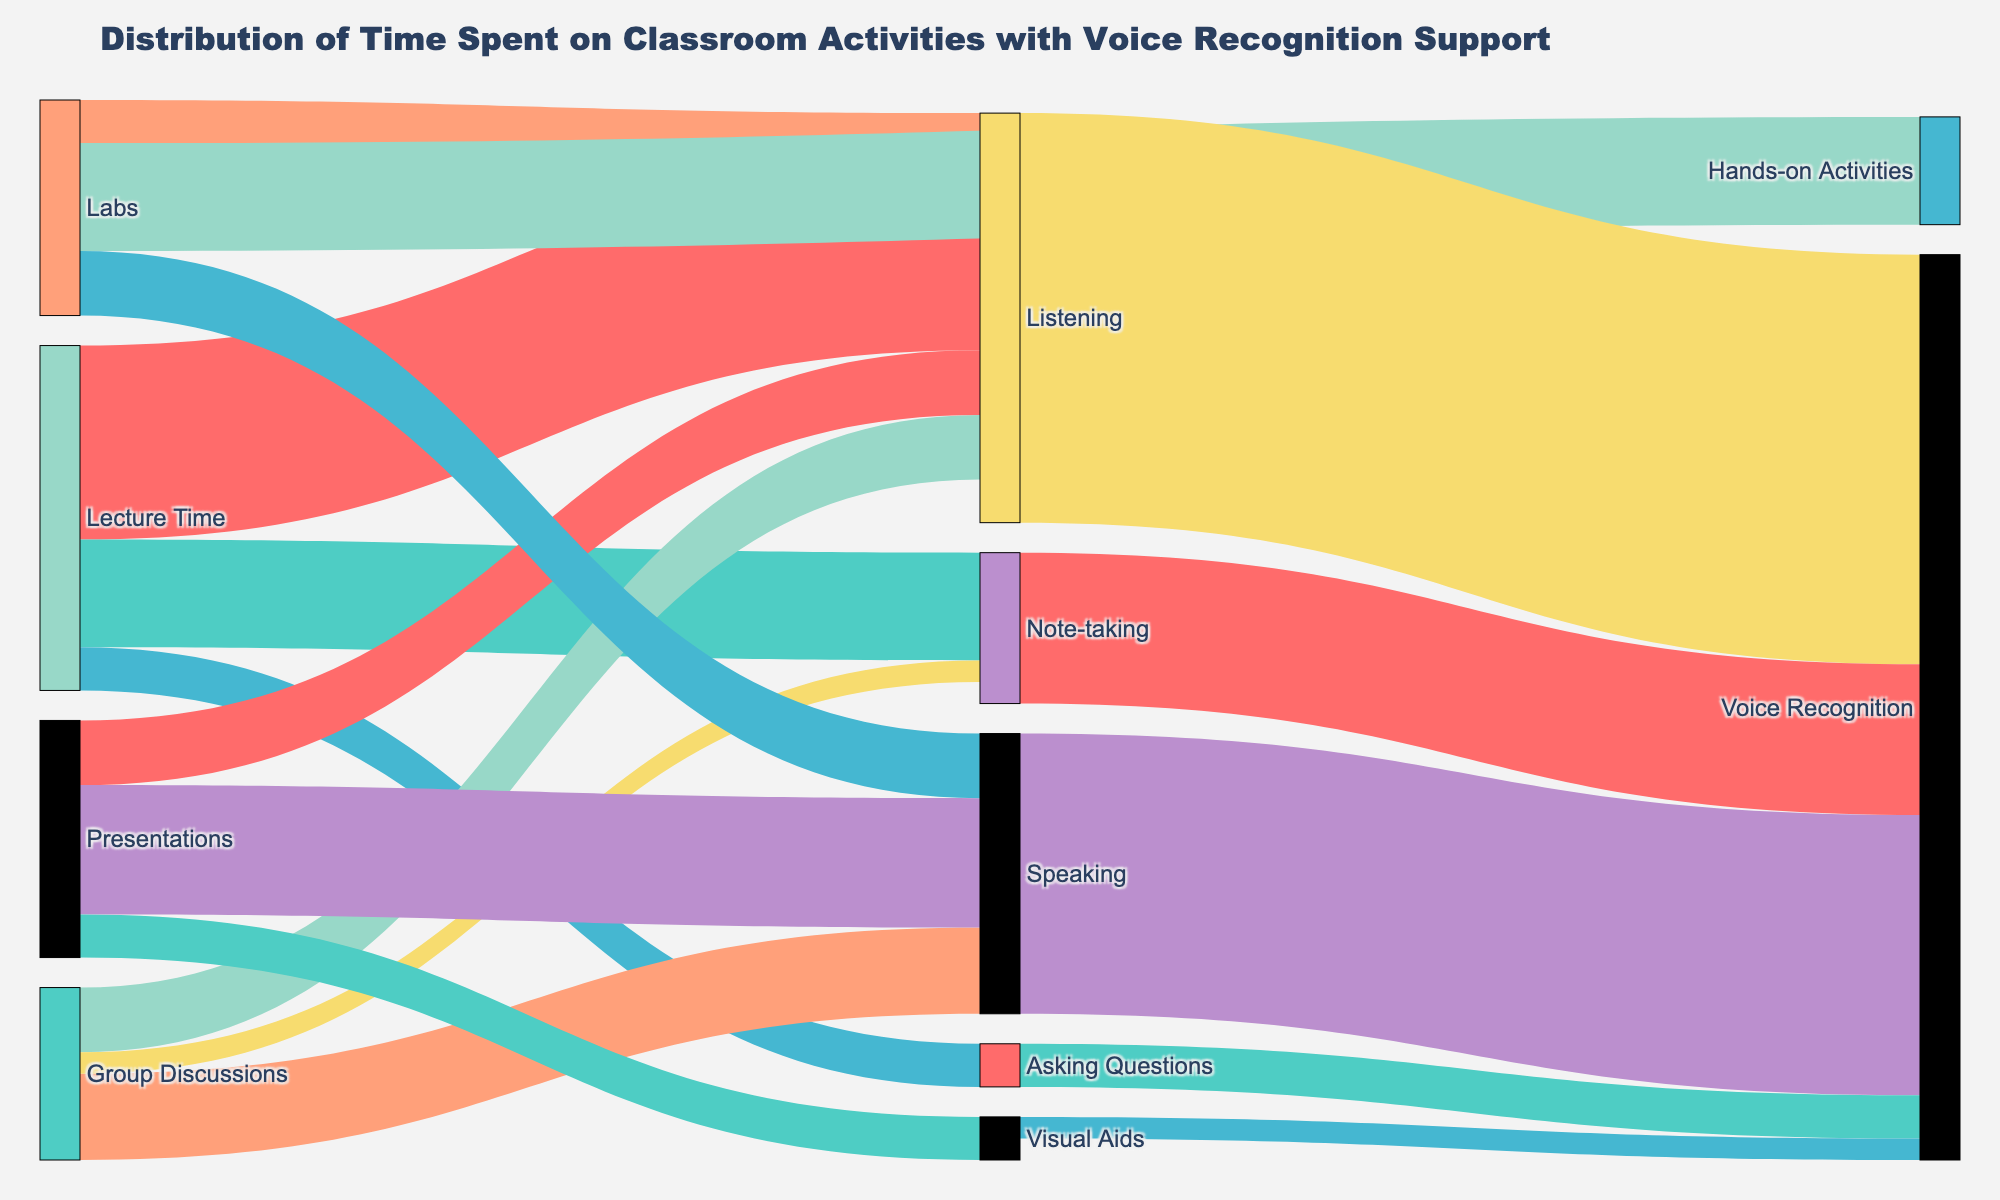What's the title of the Sankey diagram? The title of the Sankey diagram is displayed at the top of the figure.
Answer: Distribution of Time Spent on Classroom Activities with Voice Recognition Support What percentage of lecture time is spent on note-taking? The Sankey diagram shows the distribution of lecture time into listening, note-taking, and asking questions. Note-taking takes up 25 units out of a total of 80 units (45 listening + 25 note-taking + 10 asking questions). To find the percentage, use the formula (25/80) * 100.
Answer: 31.25% Which classroom activity has the highest total value associated with voice recognition support? To determine the classroom activity with the highest total value for voice recognition support, sum the values going into each target under "Voice Recognition." Listening: 95, Speaking: 65, Note-taking: 35, Asking Questions: 10, Visual Aids: 5. The activity with the highest value is Listening.
Answer: Listening What is the total amount of time spent on speaking activities? To find the total time spent on speaking activities, sum all the values related to speaking: Group Discussions (20), Presentations (30), and Labs (15). So, 20 + 30 + 15 = 65.
Answer: 65 How much time is spent on hands-on activities in labs compared to note-taking in group discussions? The Sankey diagram shows that 25 units are spent on hands-on activities in labs and 5 units on note-taking in group discussions. To find the difference, subtract 5 from 25.
Answer: 20 Which activity within group discussions occupies the smallest time? The Sankey diagram lists the activities within group discussions as speaking, listening, and note-taking with values of 20, 15, and 5 respectively. The smallest value is for note-taking.
Answer: Note-taking How much more time is spent on asking questions compared to visual aids in presentations? The Sankey diagram shows that 10 units are spent on asking questions and 10 units on visual aids. The time spent is the same in both activities, so the difference is zero.
Answer: 0 What is the most significant source activity that leads to voice recognition? Identify the links from source activities to "Voice Recognition" as the target and find the highest value. Listening has the highest value at 95 units.
Answer: Listening What's the total time spent on various activities in labs? Sum the values associated with labs: Speaking (15), Listening (10), and Hands-on Activities (25). The total time is 15 + 10 + 25, which equals 50.
Answer: 50 